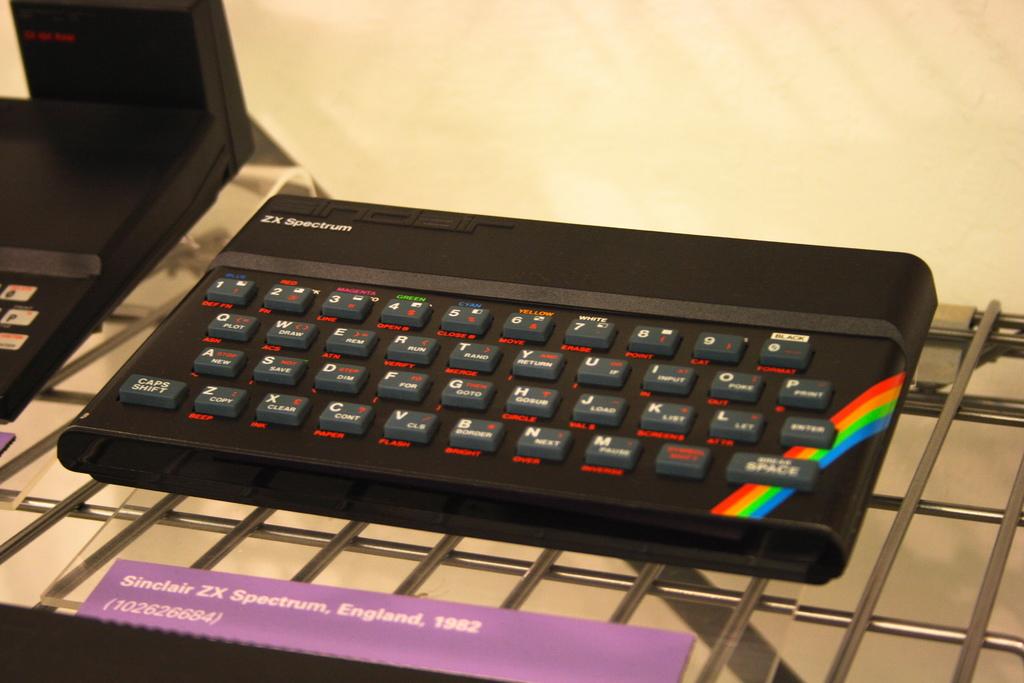In what country is this keyboard made?
Keep it short and to the point. England. What is the name of the spectrum?
Your answer should be compact. Sinclair zx. 